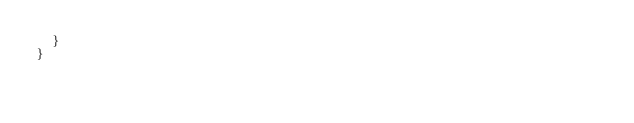Convert code to text. <code><loc_0><loc_0><loc_500><loc_500><_TypeScript_>  }
}
</code> 